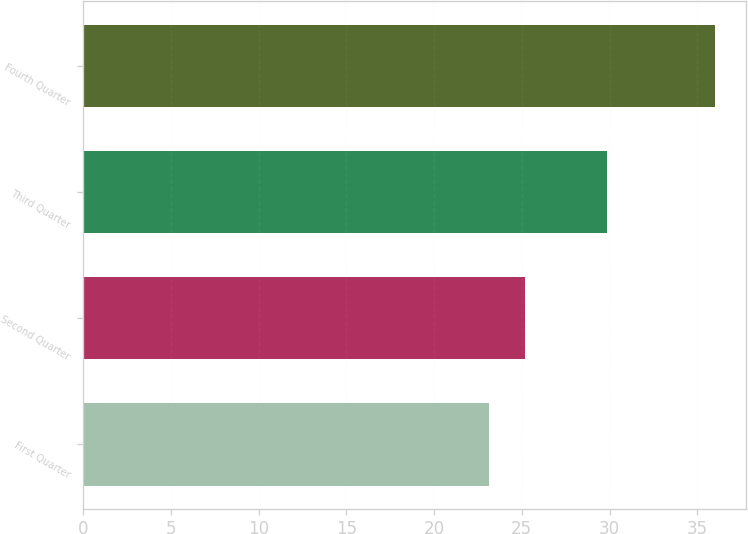Convert chart to OTSL. <chart><loc_0><loc_0><loc_500><loc_500><bar_chart><fcel>First Quarter<fcel>Second Quarter<fcel>Third Quarter<fcel>Fourth Quarter<nl><fcel>23.14<fcel>25.19<fcel>29.84<fcel>36<nl></chart> 